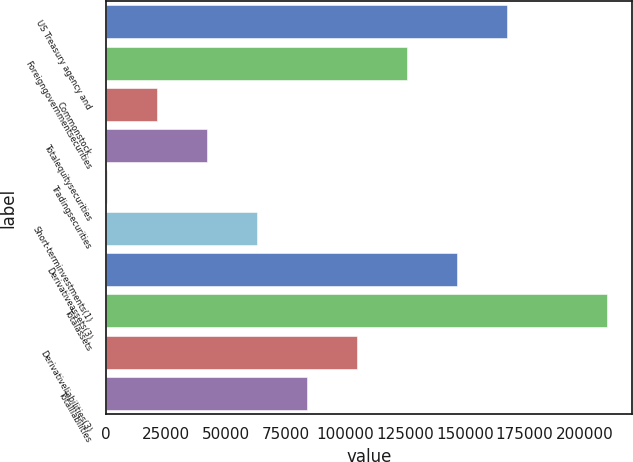<chart> <loc_0><loc_0><loc_500><loc_500><bar_chart><fcel>US Treasury agency and<fcel>Foreigngovernmentsecurities<fcel>Commonstock<fcel>Totalequitysecurities<fcel>Tradingsecurities<fcel>Short-terminvestments(1)<fcel>Derivativeassets(3)<fcel>Totalassets<fcel>Derivativeliabilities(3)<fcel>Totalliabilities<nl><fcel>167562<fcel>125718<fcel>21106.3<fcel>42028.6<fcel>184<fcel>62950.9<fcel>146640<fcel>209407<fcel>104796<fcel>83873.2<nl></chart> 